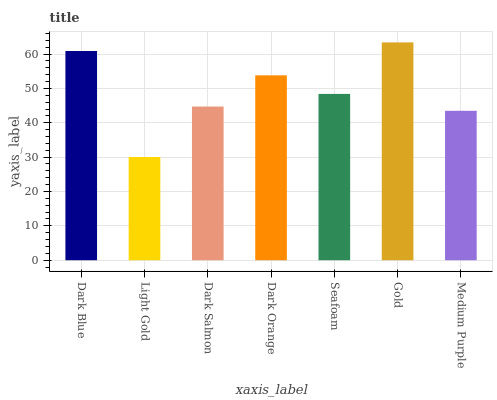Is Light Gold the minimum?
Answer yes or no. Yes. Is Gold the maximum?
Answer yes or no. Yes. Is Dark Salmon the minimum?
Answer yes or no. No. Is Dark Salmon the maximum?
Answer yes or no. No. Is Dark Salmon greater than Light Gold?
Answer yes or no. Yes. Is Light Gold less than Dark Salmon?
Answer yes or no. Yes. Is Light Gold greater than Dark Salmon?
Answer yes or no. No. Is Dark Salmon less than Light Gold?
Answer yes or no. No. Is Seafoam the high median?
Answer yes or no. Yes. Is Seafoam the low median?
Answer yes or no. Yes. Is Gold the high median?
Answer yes or no. No. Is Dark Salmon the low median?
Answer yes or no. No. 